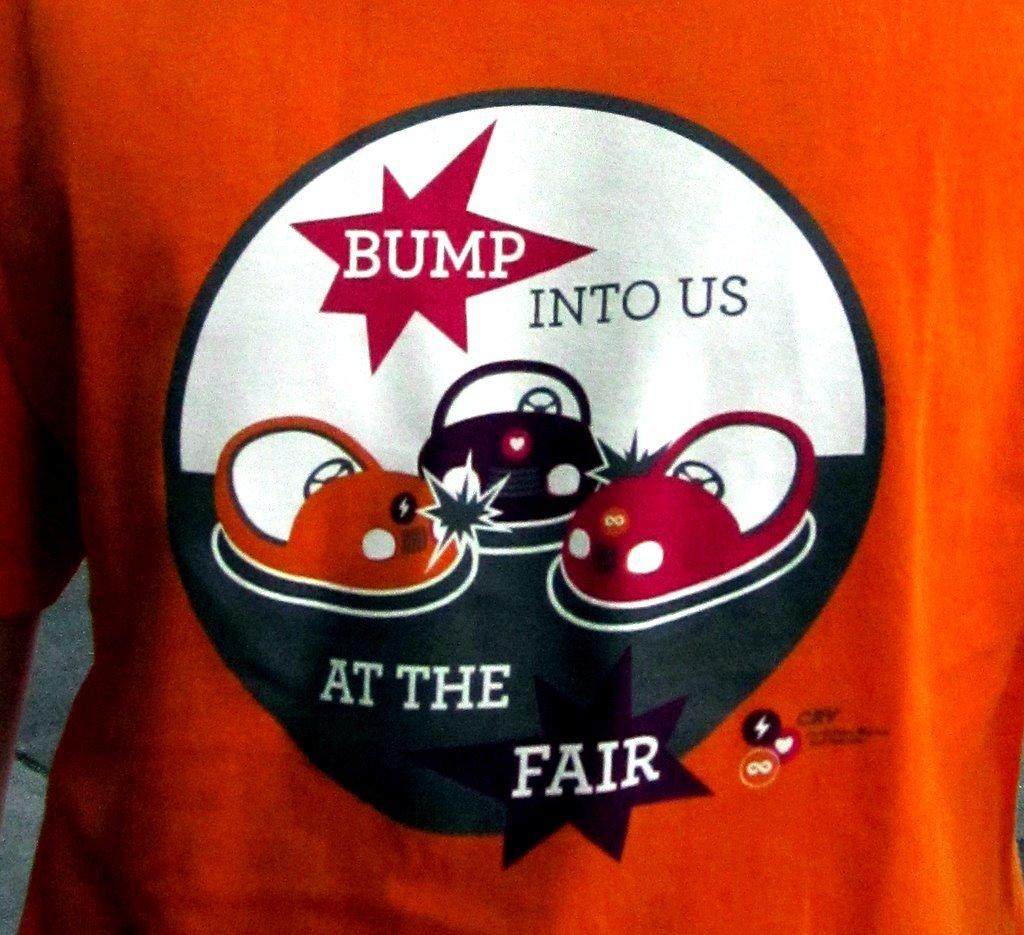What color is the t-shirt in the image? The t-shirt in the image is red. What is featured on the t-shirt besides its color? The t-shirt has text and images on it. What shape is the quince on the table in the image? There is no quince or table present in the image; it only features a red t-shirt with text and images on it. 